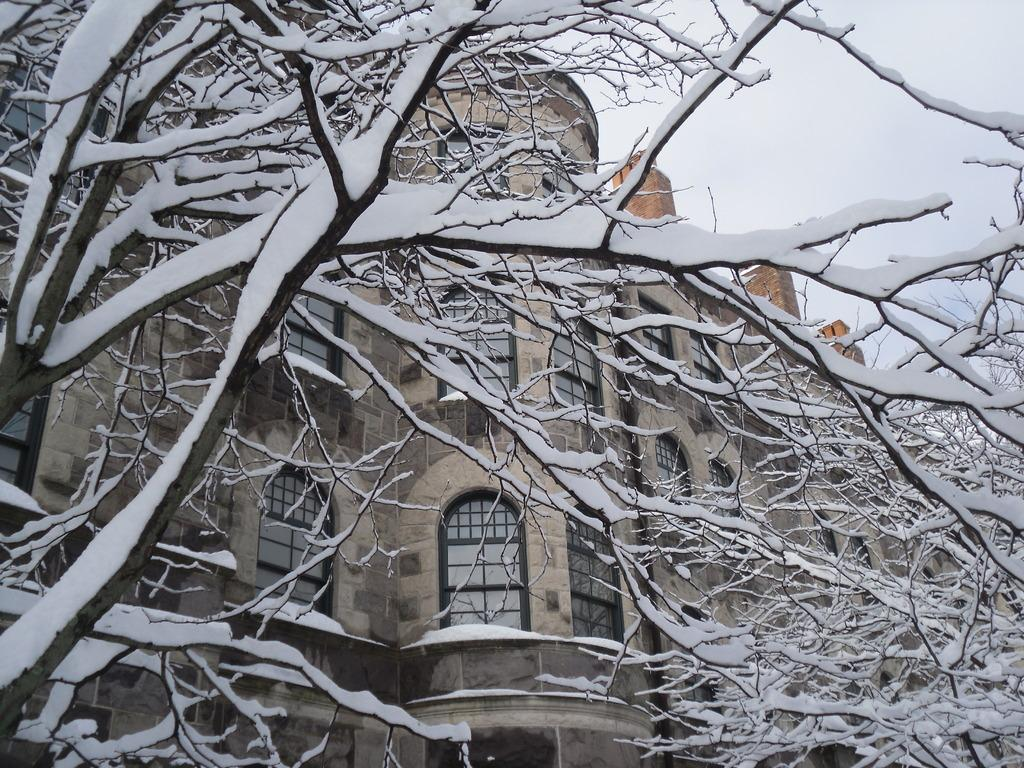What is covering the trees in the image? There is snow on the trees in the image. What structure can be seen behind the trees? There is a building with windows visible behind the trees. What is visible in the furthest in the background of the image? The sky is visible behind the building. What type of bun is being used to create smoke in the image? There is no bun or smoke present in the image. Is there a flame visible in the image? No, there is no flame visible in the image. 